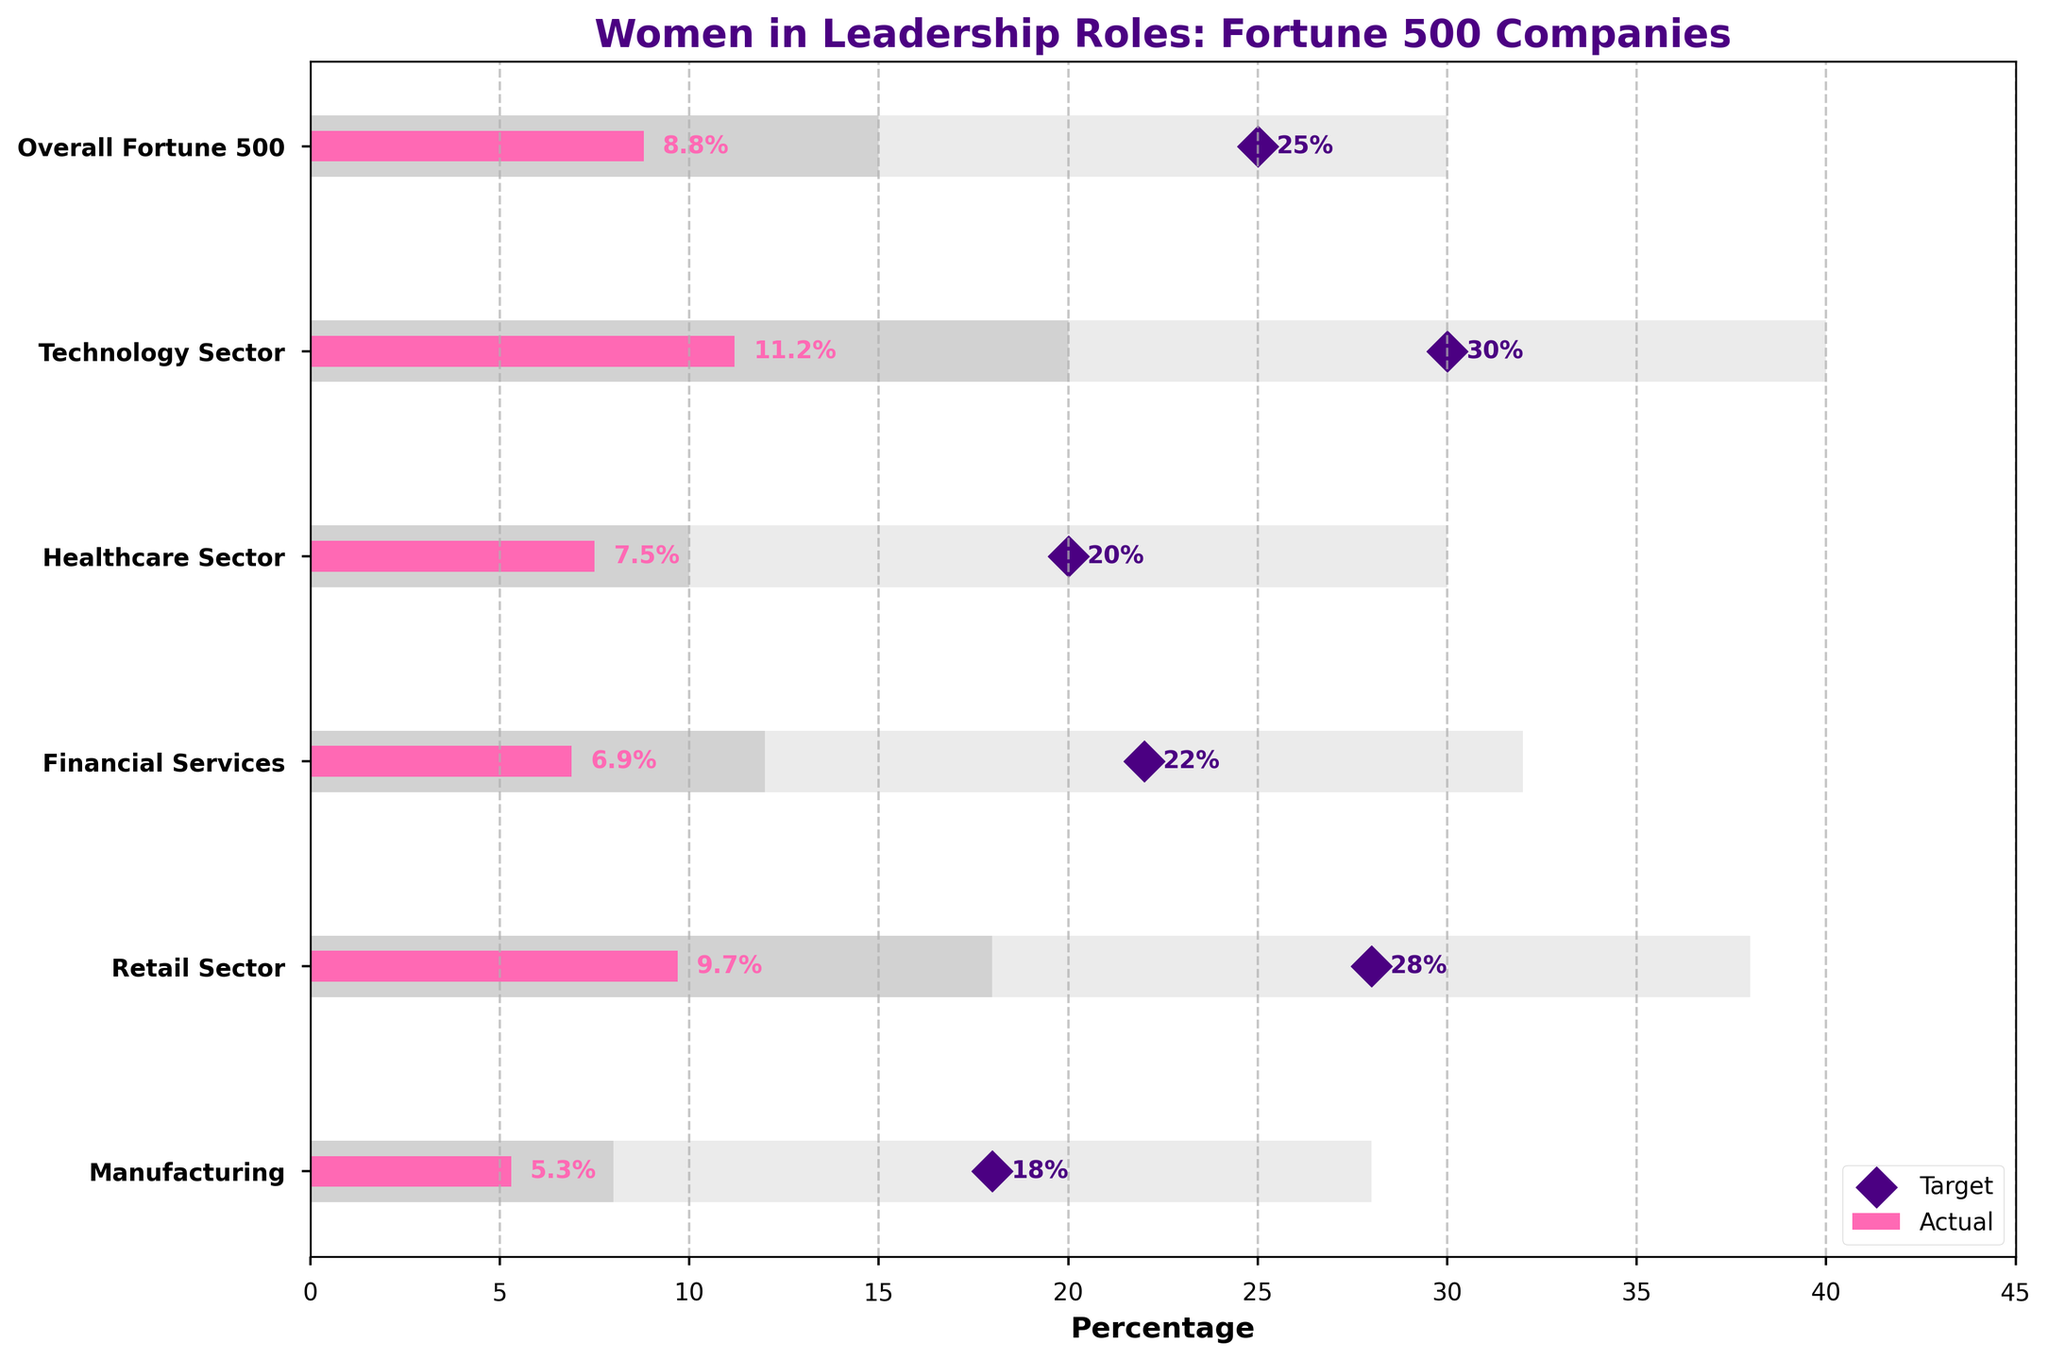What is the title of the chart? The title of a chart is usually located at the top center of the figure and provides a summary of the chart's content.
Answer: Women in Leadership Roles: Fortune 500 Companies What sector has the highest percentage of women in leadership roles? The heights of the pink bars represent the actual percentages of women in leadership roles. By comparing the heights, we can see the Technology Sector has the tallest pink bar.
Answer: Technology Sector What is the target percentage of women in leadership roles in the Healthcare Sector? The diamond markers on the horizontal lines represent the target percentages. For the Healthcare Sector, the marker is placed at 20%.
Answer: 20% Among the sectors displayed, which one has the lowest actual percentage of women in leadership roles? The pink bars represent the actual percentages. The Manufacturing sector has the shortest pink bar.
Answer: Manufacturing How does the actual percentage of women in leadership roles in the Retail Sector compare to its target percentage? The pink bar for the Retail Sector represents its actual percentage (9.7%), and the diamond marker at 28% represents the target. The actual percentage is significantly lower than the target.
Answer: 9.7% is less than 28% Which sector has the smallest gap between the actual and target percentages of women in leadership roles? The gap is found by calculating the difference between the target percentage (diamond) and the actual percentage (pink bar). The Technology sector has a gap of 30 - 11.2 = 18.8, which is the smallest.
Answer: Technology Sector What range is considered as a high range for the Financial Services sector? The horizontal bars with different shades represent low, mid, and high ranges. For Financial Services, the high range is from 12% to 32%.
Answer: 12% to 32% Which sectors have an actual percentage of women in leadership roles within the mid-range of their respective targets? The darker shaded bar represents the mid-range. The Technology Sector (11.2%) falls within its mid-range (20%), and the Retail Sector (9.7%) also falls within its mid-range (18-38%).
Answer: Technology and Retail What is the average actual percentage of women in leadership roles across all sectors? The actual percentages are: 8.8, 11.2, 7.5, 6.9, 9.7, and 5.3. Sum these values and then divide by the number of sectors (6): (8.8 + 11.2 + 7.5 + 6.9 + 9.7 + 5.3) / 6 ≈ 8.23%.
Answer: 8.23% How far is Manufacturing from reaching its target percentage? Subtract the actual percentage (5.3%) from the target (18%): 18 - 5.3 = 12.7%.
Answer: 12.7% 